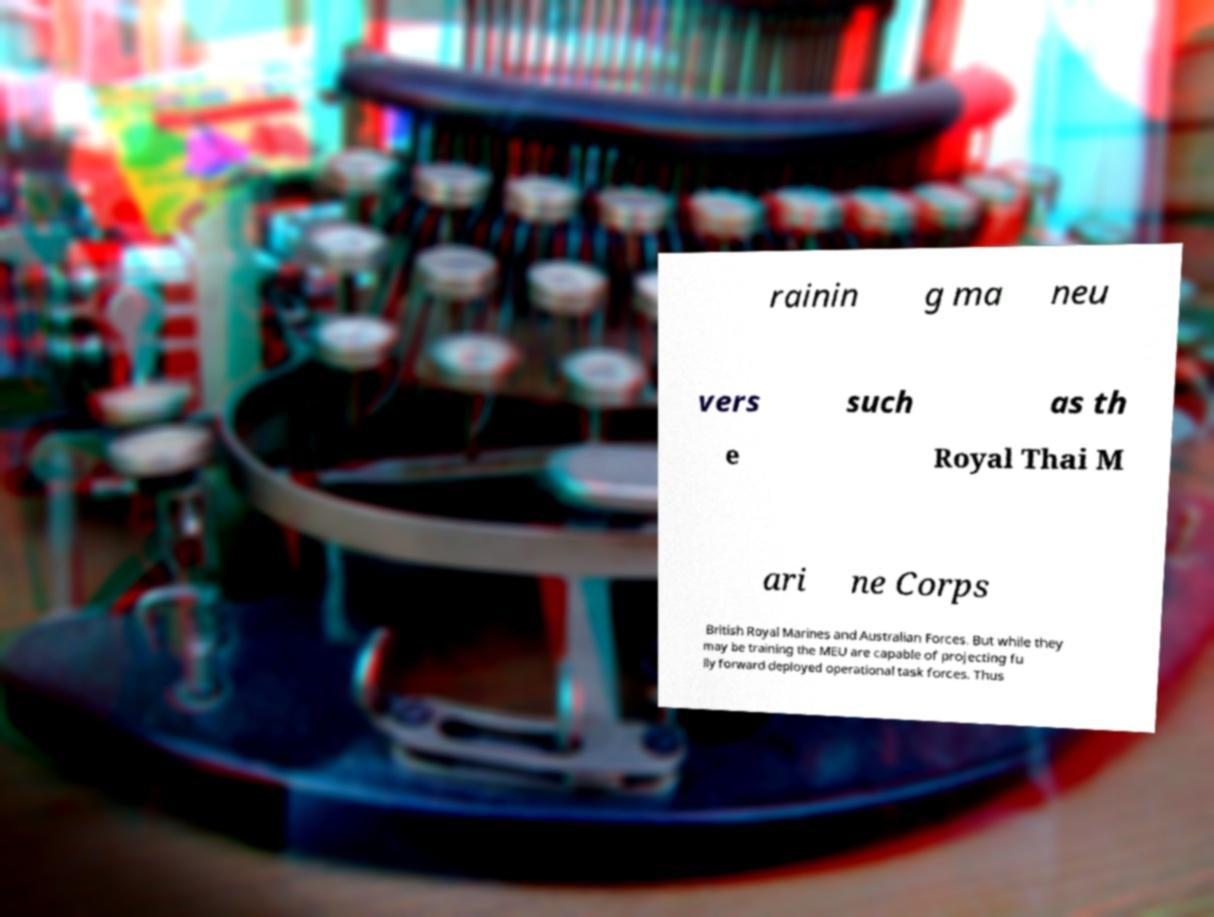I need the written content from this picture converted into text. Can you do that? rainin g ma neu vers such as th e Royal Thai M ari ne Corps British Royal Marines and Australian Forces. But while they may be training the MEU are capable of projecting fu lly forward deployed operational task forces. Thus 